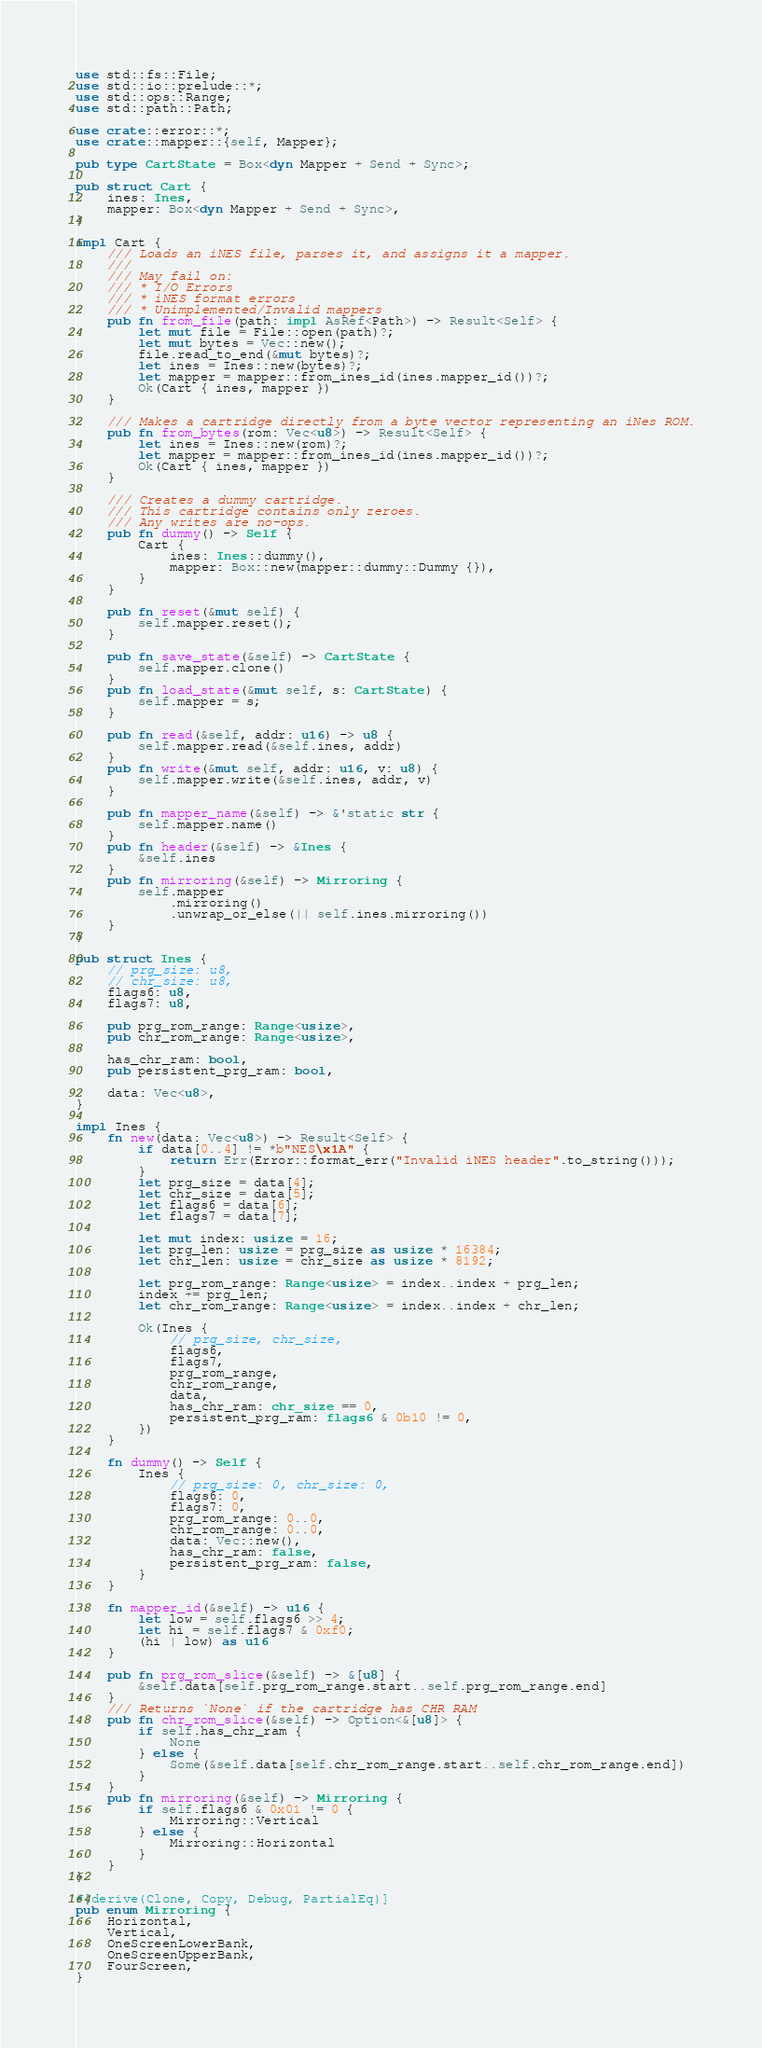<code> <loc_0><loc_0><loc_500><loc_500><_Rust_>use std::fs::File;
use std::io::prelude::*;
use std::ops::Range;
use std::path::Path;

use crate::error::*;
use crate::mapper::{self, Mapper};

pub type CartState = Box<dyn Mapper + Send + Sync>;

pub struct Cart {
    ines: Ines,
    mapper: Box<dyn Mapper + Send + Sync>,
}

impl Cart {
    /// Loads an iNES file, parses it, and assigns it a mapper.
    ///
    /// May fail on:
    /// * I/O Errors
    /// * iNES format errors
    /// * Unimplemented/Invalid mappers
    pub fn from_file(path: impl AsRef<Path>) -> Result<Self> {
        let mut file = File::open(path)?;
        let mut bytes = Vec::new();
        file.read_to_end(&mut bytes)?;
        let ines = Ines::new(bytes)?;
        let mapper = mapper::from_ines_id(ines.mapper_id())?;
        Ok(Cart { ines, mapper })
    }

    /// Makes a cartridge directly from a byte vector representing an iNes ROM.
    pub fn from_bytes(rom: Vec<u8>) -> Result<Self> {
        let ines = Ines::new(rom)?;
        let mapper = mapper::from_ines_id(ines.mapper_id())?;
        Ok(Cart { ines, mapper })
    }

    /// Creates a dummy cartridge.
    /// This cartridge contains only zeroes.
    /// Any writes are no-ops.
    pub fn dummy() -> Self {
        Cart {
            ines: Ines::dummy(),
            mapper: Box::new(mapper::dummy::Dummy {}),
        }
    }

    pub fn reset(&mut self) {
        self.mapper.reset();
    }

    pub fn save_state(&self) -> CartState {
        self.mapper.clone()
    }
    pub fn load_state(&mut self, s: CartState) {
        self.mapper = s;
    }

    pub fn read(&self, addr: u16) -> u8 {
        self.mapper.read(&self.ines, addr)
    }
    pub fn write(&mut self, addr: u16, v: u8) {
        self.mapper.write(&self.ines, addr, v)
    }

    pub fn mapper_name(&self) -> &'static str {
        self.mapper.name()
    }
    pub fn header(&self) -> &Ines {
        &self.ines
    }
    pub fn mirroring(&self) -> Mirroring {
        self.mapper
            .mirroring()
            .unwrap_or_else(|| self.ines.mirroring())
    }
}

pub struct Ines {
    // prg_size: u8,
    // chr_size: u8,
    flags6: u8,
    flags7: u8,

    pub prg_rom_range: Range<usize>,
    pub chr_rom_range: Range<usize>,

    has_chr_ram: bool,
    pub persistent_prg_ram: bool,

    data: Vec<u8>,
}

impl Ines {
    fn new(data: Vec<u8>) -> Result<Self> {
        if data[0..4] != *b"NES\x1A" {
            return Err(Error::format_err("Invalid iNES header".to_string()));
        }
        let prg_size = data[4];
        let chr_size = data[5];
        let flags6 = data[6];
        let flags7 = data[7];

        let mut index: usize = 16;
        let prg_len: usize = prg_size as usize * 16384;
        let chr_len: usize = chr_size as usize * 8192;

        let prg_rom_range: Range<usize> = index..index + prg_len;
        index += prg_len;
        let chr_rom_range: Range<usize> = index..index + chr_len;

        Ok(Ines {
            // prg_size, chr_size,
            flags6,
            flags7,
            prg_rom_range,
            chr_rom_range,
            data,
            has_chr_ram: chr_size == 0,
            persistent_prg_ram: flags6 & 0b10 != 0,
        })
    }

    fn dummy() -> Self {
        Ines {
            // prg_size: 0, chr_size: 0,
            flags6: 0,
            flags7: 0,
            prg_rom_range: 0..0,
            chr_rom_range: 0..0,
            data: Vec::new(),
            has_chr_ram: false,
            persistent_prg_ram: false,
        }
    }

    fn mapper_id(&self) -> u16 {
        let low = self.flags6 >> 4;
        let hi = self.flags7 & 0xf0;
        (hi | low) as u16
    }

    pub fn prg_rom_slice(&self) -> &[u8] {
        &self.data[self.prg_rom_range.start..self.prg_rom_range.end]
    }
    /// Returns `None` if the cartridge has CHR RAM
    pub fn chr_rom_slice(&self) -> Option<&[u8]> {
        if self.has_chr_ram {
            None
        } else {
            Some(&self.data[self.chr_rom_range.start..self.chr_rom_range.end])
        }
    }
    pub fn mirroring(&self) -> Mirroring {
        if self.flags6 & 0x01 != 0 {
            Mirroring::Vertical
        } else {
            Mirroring::Horizontal
        }
    }
}

#[derive(Clone, Copy, Debug, PartialEq)]
pub enum Mirroring {
    Horizontal,
    Vertical,
    OneScreenLowerBank,
    OneScreenUpperBank,
    FourScreen,
}
</code> 